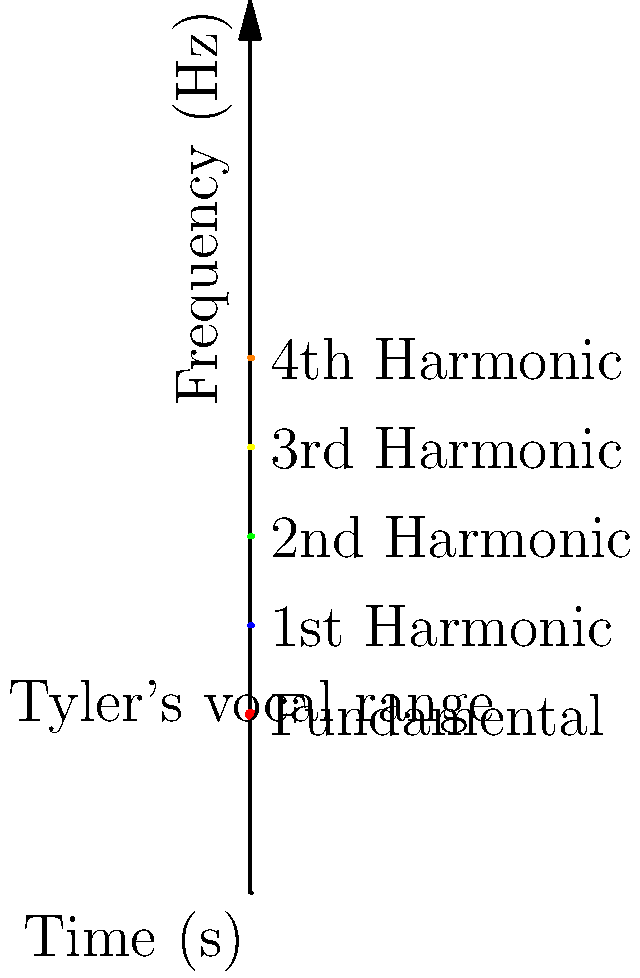In this spectrogram of Tyler Hubbard's singing, what is the approximate fundamental frequency range of his voice based on the highlighted section? To determine Tyler Hubbard's fundamental frequency range from the spectrogram:

1. Identify the lowest line in the spectrogram, which represents the fundamental frequency.
2. Locate the highlighted red section on this fundamental frequency line.
3. The highlighted section spans from approximately 2 seconds to 4 seconds on the time axis.
4. At this time range, the fundamental frequency line is at about 1000 Hz.
5. Since the highlight is a straight line, it indicates that Tyler's fundamental frequency remains constant in this segment.
6. Therefore, Tyler's vocal range in this particular segment is centered around 1000 Hz.

To convert this to a musical note:
1. The formula for converting frequency (f) to MIDI note number (n) is:
   $n = 69 + 12 * \log_2(\frac{f}{440})$
2. Plugging in 1000 Hz:
   $n = 69 + 12 * \log_2(\frac{1000}{440}) \approx 83$
3. MIDI note 83 corresponds to the note B5.

Thus, in this segment, Tyler Hubbard is singing close to the note B5, which is in the tenor range and typical for many male pop and country singers.
Answer: Approximately 1000 Hz (B5) 